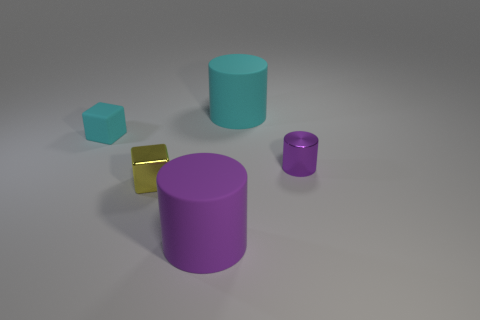Add 3 blocks. How many objects exist? 8 Subtract all cubes. How many objects are left? 3 Subtract all small blue metal cylinders. Subtract all small cyan objects. How many objects are left? 4 Add 5 big matte things. How many big matte things are left? 7 Add 5 large matte cylinders. How many large matte cylinders exist? 7 Subtract 0 blue cylinders. How many objects are left? 5 